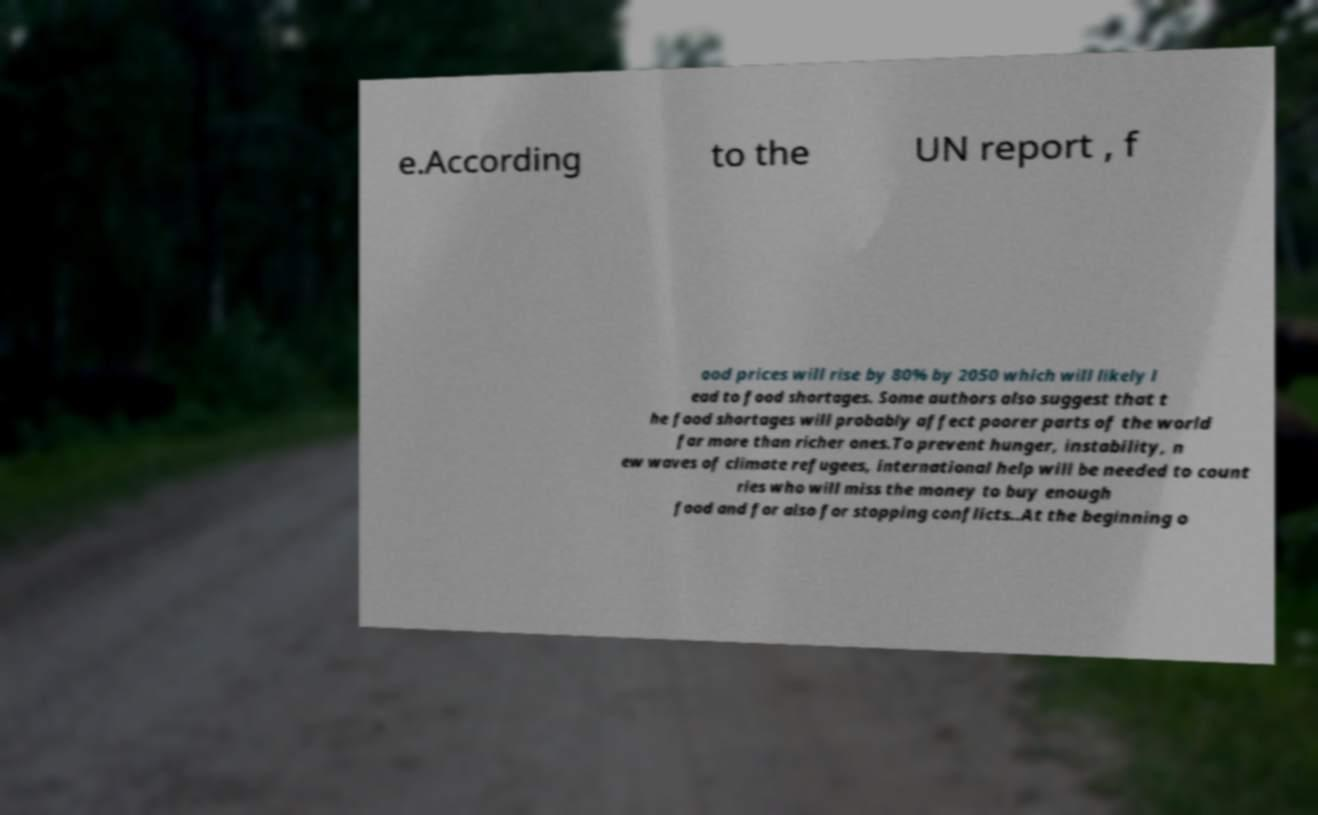Could you assist in decoding the text presented in this image and type it out clearly? e.According to the UN report , f ood prices will rise by 80% by 2050 which will likely l ead to food shortages. Some authors also suggest that t he food shortages will probably affect poorer parts of the world far more than richer ones.To prevent hunger, instability, n ew waves of climate refugees, international help will be needed to count ries who will miss the money to buy enough food and for also for stopping conflicts..At the beginning o 